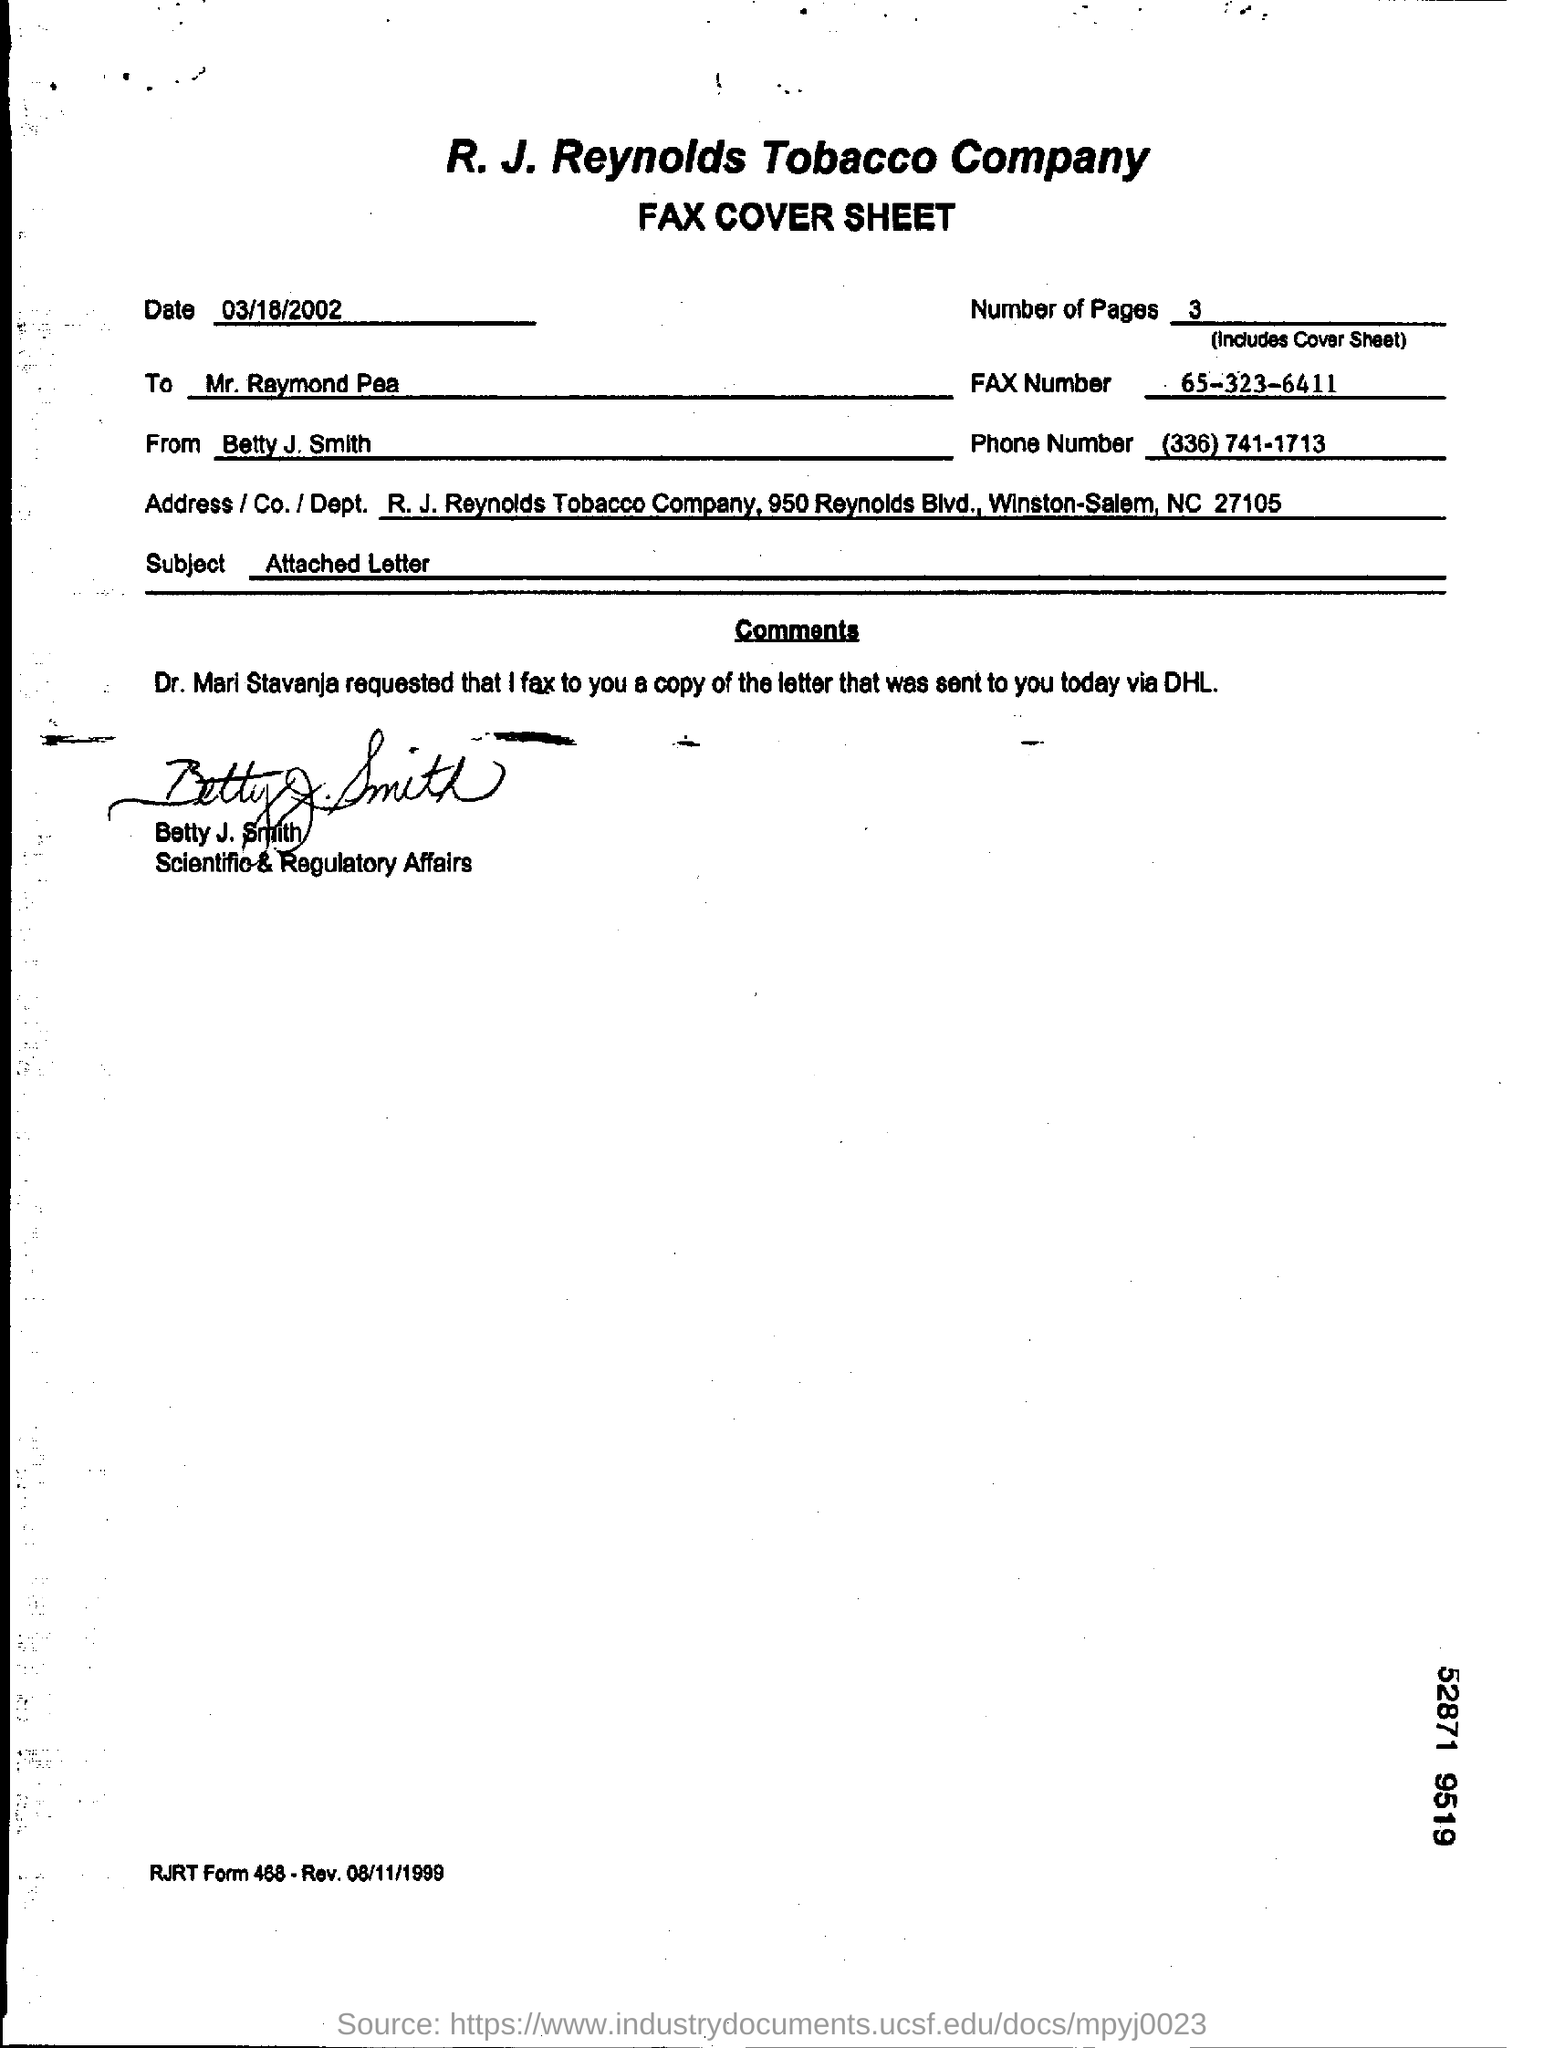Indicate a few pertinent items in this graphic. The fax cover sheet is dated March 18, 2002. The subject line of the email reads, 'What is written on the subject line? Attached Letter...' The fax number given is 65-323-6411. There are 3 pages including the cover sheet in total. 